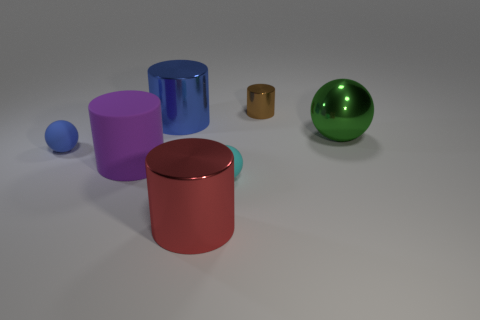Do the big blue shiny object and the small blue thing have the same shape?
Give a very brief answer. No. How many large spheres are made of the same material as the big blue cylinder?
Your response must be concise. 1. There is a brown shiny thing that is the same shape as the red shiny thing; what size is it?
Your answer should be very brief. Small. Is the size of the purple object the same as the blue shiny cylinder?
Provide a succinct answer. Yes. What shape is the matte thing to the right of the large metallic thing in front of the small ball that is on the right side of the big purple thing?
Make the answer very short. Sphere. What is the color of the other rubber thing that is the same shape as the small cyan thing?
Offer a terse response. Blue. What is the size of the thing that is behind the big matte cylinder and on the left side of the big blue shiny thing?
Your response must be concise. Small. There is a big red metal cylinder that is left of the small thing that is behind the green metallic object; what number of shiny cylinders are left of it?
Provide a short and direct response. 1. How many small things are matte things or green balls?
Offer a very short reply. 2. Is the material of the small ball that is behind the matte cylinder the same as the small cyan thing?
Your answer should be compact. Yes. 